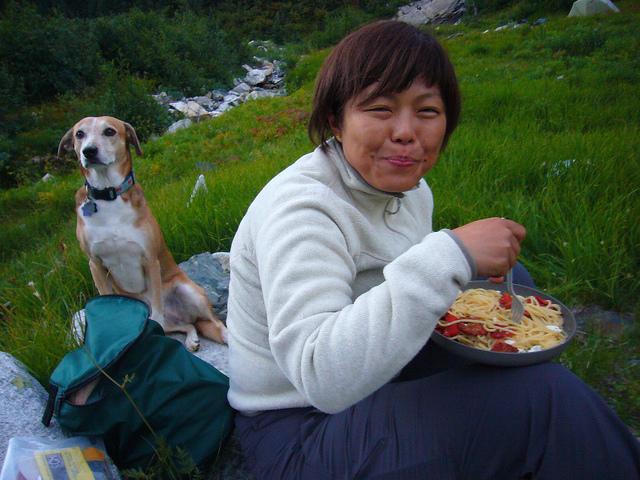What is this person eating?
Be succinct. Pasta. Where is the dog?
Keep it brief. Behind woman. Is this person smiling or frowning?
Short answer required. Smiling. Where do you think this scene took place?
Give a very brief answer. Park. 